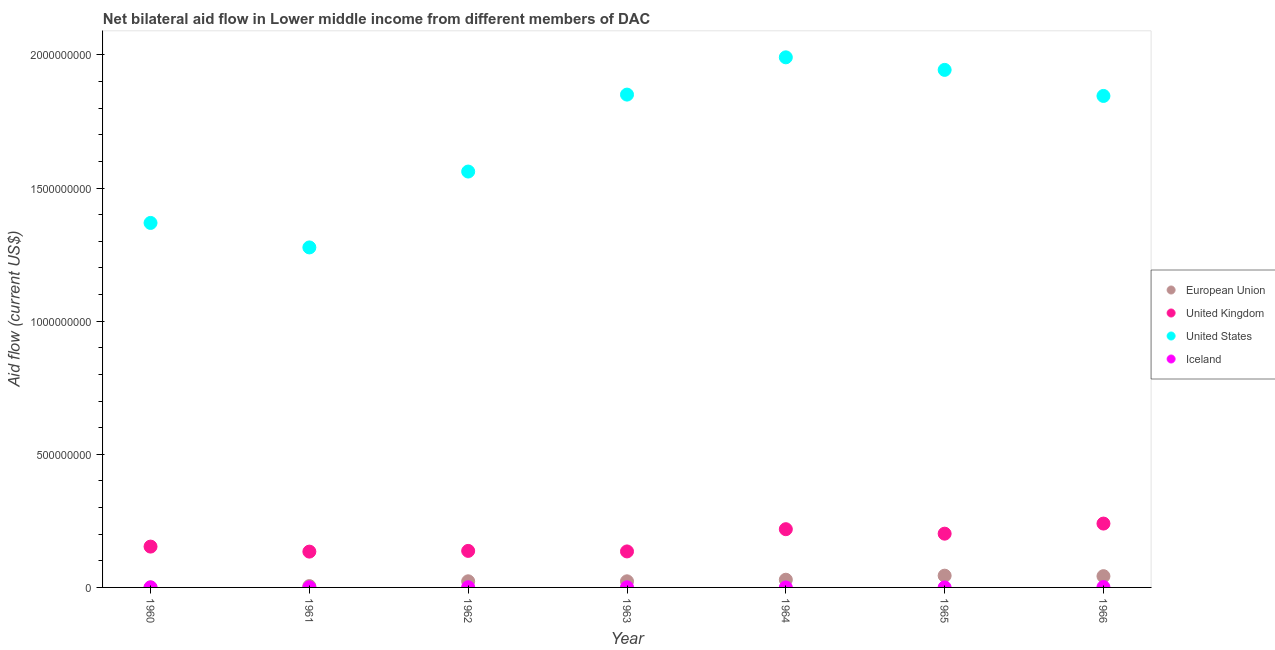What is the amount of aid given by uk in 1966?
Give a very brief answer. 2.40e+08. Across all years, what is the maximum amount of aid given by eu?
Give a very brief answer. 4.42e+07. Across all years, what is the minimum amount of aid given by uk?
Provide a succinct answer. 1.34e+08. In which year was the amount of aid given by uk maximum?
Make the answer very short. 1966. What is the total amount of aid given by iceland in the graph?
Provide a succinct answer. 3.41e+06. What is the difference between the amount of aid given by iceland in 1963 and that in 1964?
Provide a succinct answer. 4.20e+05. What is the difference between the amount of aid given by uk in 1966 and the amount of aid given by eu in 1963?
Ensure brevity in your answer.  2.17e+08. What is the average amount of aid given by us per year?
Make the answer very short. 1.69e+09. In the year 1961, what is the difference between the amount of aid given by iceland and amount of aid given by us?
Offer a very short reply. -1.28e+09. In how many years, is the amount of aid given by eu greater than 1000000000 US$?
Your answer should be compact. 0. What is the ratio of the amount of aid given by us in 1961 to that in 1966?
Make the answer very short. 0.69. Is the amount of aid given by iceland in 1963 less than that in 1965?
Offer a very short reply. No. What is the difference between the highest and the second highest amount of aid given by us?
Give a very brief answer. 4.71e+07. What is the difference between the highest and the lowest amount of aid given by iceland?
Offer a very short reply. 1.36e+06. Is it the case that in every year, the sum of the amount of aid given by eu and amount of aid given by uk is greater than the amount of aid given by us?
Make the answer very short. No. Is the amount of aid given by eu strictly greater than the amount of aid given by iceland over the years?
Ensure brevity in your answer.  Yes. Is the amount of aid given by us strictly less than the amount of aid given by iceland over the years?
Provide a succinct answer. No. How many dotlines are there?
Offer a very short reply. 4. What is the difference between two consecutive major ticks on the Y-axis?
Make the answer very short. 5.00e+08. Does the graph contain any zero values?
Offer a very short reply. No. Where does the legend appear in the graph?
Provide a short and direct response. Center right. How many legend labels are there?
Give a very brief answer. 4. What is the title of the graph?
Your answer should be compact. Net bilateral aid flow in Lower middle income from different members of DAC. What is the label or title of the X-axis?
Make the answer very short. Year. What is the label or title of the Y-axis?
Offer a terse response. Aid flow (current US$). What is the Aid flow (current US$) in United Kingdom in 1960?
Provide a succinct answer. 1.53e+08. What is the Aid flow (current US$) of United States in 1960?
Keep it short and to the point. 1.37e+09. What is the Aid flow (current US$) of Iceland in 1960?
Provide a succinct answer. 1.00e+05. What is the Aid flow (current US$) in European Union in 1961?
Keep it short and to the point. 5.04e+06. What is the Aid flow (current US$) of United Kingdom in 1961?
Provide a succinct answer. 1.34e+08. What is the Aid flow (current US$) of United States in 1961?
Make the answer very short. 1.28e+09. What is the Aid flow (current US$) of Iceland in 1961?
Your answer should be compact. 4.70e+05. What is the Aid flow (current US$) of European Union in 1962?
Make the answer very short. 2.30e+07. What is the Aid flow (current US$) of United Kingdom in 1962?
Give a very brief answer. 1.37e+08. What is the Aid flow (current US$) in United States in 1962?
Ensure brevity in your answer.  1.56e+09. What is the Aid flow (current US$) of Iceland in 1962?
Your response must be concise. 7.20e+05. What is the Aid flow (current US$) of European Union in 1963?
Your answer should be very brief. 2.30e+07. What is the Aid flow (current US$) in United Kingdom in 1963?
Your answer should be very brief. 1.35e+08. What is the Aid flow (current US$) of United States in 1963?
Keep it short and to the point. 1.85e+09. What is the Aid flow (current US$) in Iceland in 1963?
Provide a short and direct response. 5.30e+05. What is the Aid flow (current US$) of European Union in 1964?
Keep it short and to the point. 2.89e+07. What is the Aid flow (current US$) of United Kingdom in 1964?
Your response must be concise. 2.19e+08. What is the Aid flow (current US$) in United States in 1964?
Provide a succinct answer. 1.99e+09. What is the Aid flow (current US$) of Iceland in 1964?
Your answer should be compact. 1.10e+05. What is the Aid flow (current US$) of European Union in 1965?
Keep it short and to the point. 4.42e+07. What is the Aid flow (current US$) in United Kingdom in 1965?
Keep it short and to the point. 2.02e+08. What is the Aid flow (current US$) in United States in 1965?
Your answer should be compact. 1.94e+09. What is the Aid flow (current US$) in Iceland in 1965?
Make the answer very short. 6.00e+04. What is the Aid flow (current US$) in European Union in 1966?
Give a very brief answer. 4.23e+07. What is the Aid flow (current US$) in United Kingdom in 1966?
Your answer should be compact. 2.40e+08. What is the Aid flow (current US$) of United States in 1966?
Keep it short and to the point. 1.85e+09. What is the Aid flow (current US$) in Iceland in 1966?
Keep it short and to the point. 1.42e+06. Across all years, what is the maximum Aid flow (current US$) in European Union?
Your answer should be compact. 4.42e+07. Across all years, what is the maximum Aid flow (current US$) in United Kingdom?
Make the answer very short. 2.40e+08. Across all years, what is the maximum Aid flow (current US$) of United States?
Your answer should be very brief. 1.99e+09. Across all years, what is the maximum Aid flow (current US$) of Iceland?
Ensure brevity in your answer.  1.42e+06. Across all years, what is the minimum Aid flow (current US$) in United Kingdom?
Give a very brief answer. 1.34e+08. Across all years, what is the minimum Aid flow (current US$) in United States?
Offer a very short reply. 1.28e+09. What is the total Aid flow (current US$) in European Union in the graph?
Provide a succinct answer. 1.67e+08. What is the total Aid flow (current US$) of United Kingdom in the graph?
Offer a very short reply. 1.22e+09. What is the total Aid flow (current US$) in United States in the graph?
Provide a succinct answer. 1.18e+1. What is the total Aid flow (current US$) in Iceland in the graph?
Offer a very short reply. 3.41e+06. What is the difference between the Aid flow (current US$) in European Union in 1960 and that in 1961?
Offer a terse response. -4.82e+06. What is the difference between the Aid flow (current US$) of United Kingdom in 1960 and that in 1961?
Provide a succinct answer. 1.89e+07. What is the difference between the Aid flow (current US$) of United States in 1960 and that in 1961?
Offer a very short reply. 9.20e+07. What is the difference between the Aid flow (current US$) in Iceland in 1960 and that in 1961?
Give a very brief answer. -3.70e+05. What is the difference between the Aid flow (current US$) of European Union in 1960 and that in 1962?
Provide a succinct answer. -2.28e+07. What is the difference between the Aid flow (current US$) of United Kingdom in 1960 and that in 1962?
Your answer should be compact. 1.62e+07. What is the difference between the Aid flow (current US$) in United States in 1960 and that in 1962?
Ensure brevity in your answer.  -1.93e+08. What is the difference between the Aid flow (current US$) in Iceland in 1960 and that in 1962?
Your response must be concise. -6.20e+05. What is the difference between the Aid flow (current US$) in European Union in 1960 and that in 1963?
Your answer should be compact. -2.28e+07. What is the difference between the Aid flow (current US$) of United Kingdom in 1960 and that in 1963?
Ensure brevity in your answer.  1.82e+07. What is the difference between the Aid flow (current US$) of United States in 1960 and that in 1963?
Make the answer very short. -4.82e+08. What is the difference between the Aid flow (current US$) in Iceland in 1960 and that in 1963?
Your answer should be very brief. -4.30e+05. What is the difference between the Aid flow (current US$) of European Union in 1960 and that in 1964?
Offer a terse response. -2.87e+07. What is the difference between the Aid flow (current US$) of United Kingdom in 1960 and that in 1964?
Your answer should be compact. -6.54e+07. What is the difference between the Aid flow (current US$) of United States in 1960 and that in 1964?
Your answer should be compact. -6.22e+08. What is the difference between the Aid flow (current US$) in Iceland in 1960 and that in 1964?
Offer a very short reply. -10000. What is the difference between the Aid flow (current US$) in European Union in 1960 and that in 1965?
Provide a short and direct response. -4.39e+07. What is the difference between the Aid flow (current US$) of United Kingdom in 1960 and that in 1965?
Make the answer very short. -4.86e+07. What is the difference between the Aid flow (current US$) in United States in 1960 and that in 1965?
Offer a terse response. -5.75e+08. What is the difference between the Aid flow (current US$) in European Union in 1960 and that in 1966?
Your answer should be very brief. -4.20e+07. What is the difference between the Aid flow (current US$) in United Kingdom in 1960 and that in 1966?
Make the answer very short. -8.65e+07. What is the difference between the Aid flow (current US$) of United States in 1960 and that in 1966?
Ensure brevity in your answer.  -4.77e+08. What is the difference between the Aid flow (current US$) of Iceland in 1960 and that in 1966?
Provide a short and direct response. -1.32e+06. What is the difference between the Aid flow (current US$) in European Union in 1961 and that in 1962?
Ensure brevity in your answer.  -1.80e+07. What is the difference between the Aid flow (current US$) in United Kingdom in 1961 and that in 1962?
Ensure brevity in your answer.  -2.70e+06. What is the difference between the Aid flow (current US$) in United States in 1961 and that in 1962?
Your answer should be compact. -2.85e+08. What is the difference between the Aid flow (current US$) of European Union in 1961 and that in 1963?
Give a very brief answer. -1.79e+07. What is the difference between the Aid flow (current US$) in United Kingdom in 1961 and that in 1963?
Keep it short and to the point. -7.10e+05. What is the difference between the Aid flow (current US$) of United States in 1961 and that in 1963?
Your answer should be very brief. -5.74e+08. What is the difference between the Aid flow (current US$) in European Union in 1961 and that in 1964?
Offer a terse response. -2.39e+07. What is the difference between the Aid flow (current US$) of United Kingdom in 1961 and that in 1964?
Your response must be concise. -8.42e+07. What is the difference between the Aid flow (current US$) of United States in 1961 and that in 1964?
Offer a very short reply. -7.14e+08. What is the difference between the Aid flow (current US$) of Iceland in 1961 and that in 1964?
Your response must be concise. 3.60e+05. What is the difference between the Aid flow (current US$) of European Union in 1961 and that in 1965?
Your response must be concise. -3.91e+07. What is the difference between the Aid flow (current US$) in United Kingdom in 1961 and that in 1965?
Your answer should be compact. -6.74e+07. What is the difference between the Aid flow (current US$) of United States in 1961 and that in 1965?
Offer a terse response. -6.67e+08. What is the difference between the Aid flow (current US$) in Iceland in 1961 and that in 1965?
Keep it short and to the point. 4.10e+05. What is the difference between the Aid flow (current US$) of European Union in 1961 and that in 1966?
Your answer should be compact. -3.72e+07. What is the difference between the Aid flow (current US$) of United Kingdom in 1961 and that in 1966?
Give a very brief answer. -1.05e+08. What is the difference between the Aid flow (current US$) of United States in 1961 and that in 1966?
Ensure brevity in your answer.  -5.69e+08. What is the difference between the Aid flow (current US$) of Iceland in 1961 and that in 1966?
Make the answer very short. -9.50e+05. What is the difference between the Aid flow (current US$) of United Kingdom in 1962 and that in 1963?
Give a very brief answer. 1.99e+06. What is the difference between the Aid flow (current US$) of United States in 1962 and that in 1963?
Give a very brief answer. -2.89e+08. What is the difference between the Aid flow (current US$) of European Union in 1962 and that in 1964?
Provide a succinct answer. -5.88e+06. What is the difference between the Aid flow (current US$) of United Kingdom in 1962 and that in 1964?
Provide a succinct answer. -8.15e+07. What is the difference between the Aid flow (current US$) in United States in 1962 and that in 1964?
Your response must be concise. -4.29e+08. What is the difference between the Aid flow (current US$) in European Union in 1962 and that in 1965?
Offer a terse response. -2.11e+07. What is the difference between the Aid flow (current US$) in United Kingdom in 1962 and that in 1965?
Offer a terse response. -6.47e+07. What is the difference between the Aid flow (current US$) of United States in 1962 and that in 1965?
Keep it short and to the point. -3.82e+08. What is the difference between the Aid flow (current US$) of Iceland in 1962 and that in 1965?
Provide a succinct answer. 6.60e+05. What is the difference between the Aid flow (current US$) of European Union in 1962 and that in 1966?
Make the answer very short. -1.92e+07. What is the difference between the Aid flow (current US$) of United Kingdom in 1962 and that in 1966?
Offer a very short reply. -1.03e+08. What is the difference between the Aid flow (current US$) in United States in 1962 and that in 1966?
Offer a very short reply. -2.84e+08. What is the difference between the Aid flow (current US$) in Iceland in 1962 and that in 1966?
Offer a very short reply. -7.00e+05. What is the difference between the Aid flow (current US$) in European Union in 1963 and that in 1964?
Your answer should be compact. -5.95e+06. What is the difference between the Aid flow (current US$) of United Kingdom in 1963 and that in 1964?
Ensure brevity in your answer.  -8.35e+07. What is the difference between the Aid flow (current US$) of United States in 1963 and that in 1964?
Your response must be concise. -1.40e+08. What is the difference between the Aid flow (current US$) in European Union in 1963 and that in 1965?
Provide a succinct answer. -2.12e+07. What is the difference between the Aid flow (current US$) of United Kingdom in 1963 and that in 1965?
Offer a terse response. -6.67e+07. What is the difference between the Aid flow (current US$) of United States in 1963 and that in 1965?
Your response must be concise. -9.29e+07. What is the difference between the Aid flow (current US$) in Iceland in 1963 and that in 1965?
Your answer should be very brief. 4.70e+05. What is the difference between the Aid flow (current US$) in European Union in 1963 and that in 1966?
Ensure brevity in your answer.  -1.93e+07. What is the difference between the Aid flow (current US$) in United Kingdom in 1963 and that in 1966?
Offer a terse response. -1.05e+08. What is the difference between the Aid flow (current US$) of United States in 1963 and that in 1966?
Offer a very short reply. 5.02e+06. What is the difference between the Aid flow (current US$) of Iceland in 1963 and that in 1966?
Offer a terse response. -8.90e+05. What is the difference between the Aid flow (current US$) in European Union in 1964 and that in 1965?
Offer a very short reply. -1.52e+07. What is the difference between the Aid flow (current US$) in United Kingdom in 1964 and that in 1965?
Make the answer very short. 1.68e+07. What is the difference between the Aid flow (current US$) in United States in 1964 and that in 1965?
Your answer should be very brief. 4.71e+07. What is the difference between the Aid flow (current US$) in European Union in 1964 and that in 1966?
Your answer should be very brief. -1.34e+07. What is the difference between the Aid flow (current US$) in United Kingdom in 1964 and that in 1966?
Provide a short and direct response. -2.11e+07. What is the difference between the Aid flow (current US$) in United States in 1964 and that in 1966?
Give a very brief answer. 1.45e+08. What is the difference between the Aid flow (current US$) in Iceland in 1964 and that in 1966?
Provide a short and direct response. -1.31e+06. What is the difference between the Aid flow (current US$) in European Union in 1965 and that in 1966?
Ensure brevity in your answer.  1.88e+06. What is the difference between the Aid flow (current US$) in United Kingdom in 1965 and that in 1966?
Your answer should be very brief. -3.79e+07. What is the difference between the Aid flow (current US$) in United States in 1965 and that in 1966?
Provide a succinct answer. 9.79e+07. What is the difference between the Aid flow (current US$) in Iceland in 1965 and that in 1966?
Your answer should be compact. -1.36e+06. What is the difference between the Aid flow (current US$) in European Union in 1960 and the Aid flow (current US$) in United Kingdom in 1961?
Your answer should be compact. -1.34e+08. What is the difference between the Aid flow (current US$) of European Union in 1960 and the Aid flow (current US$) of United States in 1961?
Offer a very short reply. -1.28e+09. What is the difference between the Aid flow (current US$) in United Kingdom in 1960 and the Aid flow (current US$) in United States in 1961?
Provide a succinct answer. -1.12e+09. What is the difference between the Aid flow (current US$) of United Kingdom in 1960 and the Aid flow (current US$) of Iceland in 1961?
Provide a short and direct response. 1.53e+08. What is the difference between the Aid flow (current US$) in United States in 1960 and the Aid flow (current US$) in Iceland in 1961?
Give a very brief answer. 1.37e+09. What is the difference between the Aid flow (current US$) in European Union in 1960 and the Aid flow (current US$) in United Kingdom in 1962?
Your response must be concise. -1.37e+08. What is the difference between the Aid flow (current US$) in European Union in 1960 and the Aid flow (current US$) in United States in 1962?
Your answer should be very brief. -1.56e+09. What is the difference between the Aid flow (current US$) of European Union in 1960 and the Aid flow (current US$) of Iceland in 1962?
Your response must be concise. -5.00e+05. What is the difference between the Aid flow (current US$) of United Kingdom in 1960 and the Aid flow (current US$) of United States in 1962?
Your answer should be compact. -1.41e+09. What is the difference between the Aid flow (current US$) of United Kingdom in 1960 and the Aid flow (current US$) of Iceland in 1962?
Provide a succinct answer. 1.53e+08. What is the difference between the Aid flow (current US$) of United States in 1960 and the Aid flow (current US$) of Iceland in 1962?
Your answer should be compact. 1.37e+09. What is the difference between the Aid flow (current US$) of European Union in 1960 and the Aid flow (current US$) of United Kingdom in 1963?
Your answer should be compact. -1.35e+08. What is the difference between the Aid flow (current US$) of European Union in 1960 and the Aid flow (current US$) of United States in 1963?
Your answer should be very brief. -1.85e+09. What is the difference between the Aid flow (current US$) in European Union in 1960 and the Aid flow (current US$) in Iceland in 1963?
Keep it short and to the point. -3.10e+05. What is the difference between the Aid flow (current US$) in United Kingdom in 1960 and the Aid flow (current US$) in United States in 1963?
Provide a succinct answer. -1.70e+09. What is the difference between the Aid flow (current US$) in United Kingdom in 1960 and the Aid flow (current US$) in Iceland in 1963?
Keep it short and to the point. 1.53e+08. What is the difference between the Aid flow (current US$) of United States in 1960 and the Aid flow (current US$) of Iceland in 1963?
Keep it short and to the point. 1.37e+09. What is the difference between the Aid flow (current US$) in European Union in 1960 and the Aid flow (current US$) in United Kingdom in 1964?
Provide a succinct answer. -2.18e+08. What is the difference between the Aid flow (current US$) in European Union in 1960 and the Aid flow (current US$) in United States in 1964?
Your response must be concise. -1.99e+09. What is the difference between the Aid flow (current US$) in United Kingdom in 1960 and the Aid flow (current US$) in United States in 1964?
Offer a terse response. -1.84e+09. What is the difference between the Aid flow (current US$) in United Kingdom in 1960 and the Aid flow (current US$) in Iceland in 1964?
Offer a very short reply. 1.53e+08. What is the difference between the Aid flow (current US$) of United States in 1960 and the Aid flow (current US$) of Iceland in 1964?
Keep it short and to the point. 1.37e+09. What is the difference between the Aid flow (current US$) in European Union in 1960 and the Aid flow (current US$) in United Kingdom in 1965?
Make the answer very short. -2.02e+08. What is the difference between the Aid flow (current US$) of European Union in 1960 and the Aid flow (current US$) of United States in 1965?
Provide a succinct answer. -1.94e+09. What is the difference between the Aid flow (current US$) in United Kingdom in 1960 and the Aid flow (current US$) in United States in 1965?
Your answer should be very brief. -1.79e+09. What is the difference between the Aid flow (current US$) of United Kingdom in 1960 and the Aid flow (current US$) of Iceland in 1965?
Offer a very short reply. 1.53e+08. What is the difference between the Aid flow (current US$) of United States in 1960 and the Aid flow (current US$) of Iceland in 1965?
Make the answer very short. 1.37e+09. What is the difference between the Aid flow (current US$) in European Union in 1960 and the Aid flow (current US$) in United Kingdom in 1966?
Offer a very short reply. -2.40e+08. What is the difference between the Aid flow (current US$) of European Union in 1960 and the Aid flow (current US$) of United States in 1966?
Your answer should be very brief. -1.85e+09. What is the difference between the Aid flow (current US$) in European Union in 1960 and the Aid flow (current US$) in Iceland in 1966?
Your answer should be compact. -1.20e+06. What is the difference between the Aid flow (current US$) of United Kingdom in 1960 and the Aid flow (current US$) of United States in 1966?
Keep it short and to the point. -1.69e+09. What is the difference between the Aid flow (current US$) of United Kingdom in 1960 and the Aid flow (current US$) of Iceland in 1966?
Provide a short and direct response. 1.52e+08. What is the difference between the Aid flow (current US$) in United States in 1960 and the Aid flow (current US$) in Iceland in 1966?
Provide a succinct answer. 1.37e+09. What is the difference between the Aid flow (current US$) in European Union in 1961 and the Aid flow (current US$) in United Kingdom in 1962?
Offer a terse response. -1.32e+08. What is the difference between the Aid flow (current US$) in European Union in 1961 and the Aid flow (current US$) in United States in 1962?
Give a very brief answer. -1.56e+09. What is the difference between the Aid flow (current US$) in European Union in 1961 and the Aid flow (current US$) in Iceland in 1962?
Provide a short and direct response. 4.32e+06. What is the difference between the Aid flow (current US$) of United Kingdom in 1961 and the Aid flow (current US$) of United States in 1962?
Offer a terse response. -1.43e+09. What is the difference between the Aid flow (current US$) of United Kingdom in 1961 and the Aid flow (current US$) of Iceland in 1962?
Keep it short and to the point. 1.34e+08. What is the difference between the Aid flow (current US$) of United States in 1961 and the Aid flow (current US$) of Iceland in 1962?
Provide a succinct answer. 1.28e+09. What is the difference between the Aid flow (current US$) of European Union in 1961 and the Aid flow (current US$) of United Kingdom in 1963?
Make the answer very short. -1.30e+08. What is the difference between the Aid flow (current US$) of European Union in 1961 and the Aid flow (current US$) of United States in 1963?
Provide a short and direct response. -1.85e+09. What is the difference between the Aid flow (current US$) of European Union in 1961 and the Aid flow (current US$) of Iceland in 1963?
Make the answer very short. 4.51e+06. What is the difference between the Aid flow (current US$) in United Kingdom in 1961 and the Aid flow (current US$) in United States in 1963?
Ensure brevity in your answer.  -1.72e+09. What is the difference between the Aid flow (current US$) in United Kingdom in 1961 and the Aid flow (current US$) in Iceland in 1963?
Your answer should be very brief. 1.34e+08. What is the difference between the Aid flow (current US$) of United States in 1961 and the Aid flow (current US$) of Iceland in 1963?
Make the answer very short. 1.28e+09. What is the difference between the Aid flow (current US$) in European Union in 1961 and the Aid flow (current US$) in United Kingdom in 1964?
Give a very brief answer. -2.14e+08. What is the difference between the Aid flow (current US$) in European Union in 1961 and the Aid flow (current US$) in United States in 1964?
Provide a short and direct response. -1.99e+09. What is the difference between the Aid flow (current US$) of European Union in 1961 and the Aid flow (current US$) of Iceland in 1964?
Offer a terse response. 4.93e+06. What is the difference between the Aid flow (current US$) of United Kingdom in 1961 and the Aid flow (current US$) of United States in 1964?
Offer a terse response. -1.86e+09. What is the difference between the Aid flow (current US$) in United Kingdom in 1961 and the Aid flow (current US$) in Iceland in 1964?
Your answer should be compact. 1.34e+08. What is the difference between the Aid flow (current US$) of United States in 1961 and the Aid flow (current US$) of Iceland in 1964?
Offer a very short reply. 1.28e+09. What is the difference between the Aid flow (current US$) in European Union in 1961 and the Aid flow (current US$) in United Kingdom in 1965?
Ensure brevity in your answer.  -1.97e+08. What is the difference between the Aid flow (current US$) of European Union in 1961 and the Aid flow (current US$) of United States in 1965?
Offer a very short reply. -1.94e+09. What is the difference between the Aid flow (current US$) in European Union in 1961 and the Aid flow (current US$) in Iceland in 1965?
Your answer should be very brief. 4.98e+06. What is the difference between the Aid flow (current US$) in United Kingdom in 1961 and the Aid flow (current US$) in United States in 1965?
Your answer should be compact. -1.81e+09. What is the difference between the Aid flow (current US$) in United Kingdom in 1961 and the Aid flow (current US$) in Iceland in 1965?
Give a very brief answer. 1.34e+08. What is the difference between the Aid flow (current US$) in United States in 1961 and the Aid flow (current US$) in Iceland in 1965?
Give a very brief answer. 1.28e+09. What is the difference between the Aid flow (current US$) of European Union in 1961 and the Aid flow (current US$) of United Kingdom in 1966?
Offer a very short reply. -2.35e+08. What is the difference between the Aid flow (current US$) in European Union in 1961 and the Aid flow (current US$) in United States in 1966?
Provide a short and direct response. -1.84e+09. What is the difference between the Aid flow (current US$) in European Union in 1961 and the Aid flow (current US$) in Iceland in 1966?
Ensure brevity in your answer.  3.62e+06. What is the difference between the Aid flow (current US$) of United Kingdom in 1961 and the Aid flow (current US$) of United States in 1966?
Ensure brevity in your answer.  -1.71e+09. What is the difference between the Aid flow (current US$) in United Kingdom in 1961 and the Aid flow (current US$) in Iceland in 1966?
Offer a very short reply. 1.33e+08. What is the difference between the Aid flow (current US$) of United States in 1961 and the Aid flow (current US$) of Iceland in 1966?
Provide a short and direct response. 1.28e+09. What is the difference between the Aid flow (current US$) of European Union in 1962 and the Aid flow (current US$) of United Kingdom in 1963?
Give a very brief answer. -1.12e+08. What is the difference between the Aid flow (current US$) in European Union in 1962 and the Aid flow (current US$) in United States in 1963?
Give a very brief answer. -1.83e+09. What is the difference between the Aid flow (current US$) of European Union in 1962 and the Aid flow (current US$) of Iceland in 1963?
Make the answer very short. 2.25e+07. What is the difference between the Aid flow (current US$) of United Kingdom in 1962 and the Aid flow (current US$) of United States in 1963?
Provide a succinct answer. -1.71e+09. What is the difference between the Aid flow (current US$) in United Kingdom in 1962 and the Aid flow (current US$) in Iceland in 1963?
Offer a very short reply. 1.37e+08. What is the difference between the Aid flow (current US$) in United States in 1962 and the Aid flow (current US$) in Iceland in 1963?
Give a very brief answer. 1.56e+09. What is the difference between the Aid flow (current US$) of European Union in 1962 and the Aid flow (current US$) of United Kingdom in 1964?
Provide a succinct answer. -1.96e+08. What is the difference between the Aid flow (current US$) in European Union in 1962 and the Aid flow (current US$) in United States in 1964?
Offer a very short reply. -1.97e+09. What is the difference between the Aid flow (current US$) in European Union in 1962 and the Aid flow (current US$) in Iceland in 1964?
Offer a terse response. 2.29e+07. What is the difference between the Aid flow (current US$) of United Kingdom in 1962 and the Aid flow (current US$) of United States in 1964?
Give a very brief answer. -1.85e+09. What is the difference between the Aid flow (current US$) of United Kingdom in 1962 and the Aid flow (current US$) of Iceland in 1964?
Your answer should be compact. 1.37e+08. What is the difference between the Aid flow (current US$) of United States in 1962 and the Aid flow (current US$) of Iceland in 1964?
Give a very brief answer. 1.56e+09. What is the difference between the Aid flow (current US$) in European Union in 1962 and the Aid flow (current US$) in United Kingdom in 1965?
Your answer should be very brief. -1.79e+08. What is the difference between the Aid flow (current US$) of European Union in 1962 and the Aid flow (current US$) of United States in 1965?
Provide a succinct answer. -1.92e+09. What is the difference between the Aid flow (current US$) of European Union in 1962 and the Aid flow (current US$) of Iceland in 1965?
Give a very brief answer. 2.30e+07. What is the difference between the Aid flow (current US$) of United Kingdom in 1962 and the Aid flow (current US$) of United States in 1965?
Make the answer very short. -1.81e+09. What is the difference between the Aid flow (current US$) in United Kingdom in 1962 and the Aid flow (current US$) in Iceland in 1965?
Your answer should be compact. 1.37e+08. What is the difference between the Aid flow (current US$) of United States in 1962 and the Aid flow (current US$) of Iceland in 1965?
Your answer should be very brief. 1.56e+09. What is the difference between the Aid flow (current US$) of European Union in 1962 and the Aid flow (current US$) of United Kingdom in 1966?
Give a very brief answer. -2.17e+08. What is the difference between the Aid flow (current US$) of European Union in 1962 and the Aid flow (current US$) of United States in 1966?
Your answer should be very brief. -1.82e+09. What is the difference between the Aid flow (current US$) of European Union in 1962 and the Aid flow (current US$) of Iceland in 1966?
Make the answer very short. 2.16e+07. What is the difference between the Aid flow (current US$) of United Kingdom in 1962 and the Aid flow (current US$) of United States in 1966?
Provide a short and direct response. -1.71e+09. What is the difference between the Aid flow (current US$) of United Kingdom in 1962 and the Aid flow (current US$) of Iceland in 1966?
Your answer should be compact. 1.36e+08. What is the difference between the Aid flow (current US$) in United States in 1962 and the Aid flow (current US$) in Iceland in 1966?
Your answer should be very brief. 1.56e+09. What is the difference between the Aid flow (current US$) in European Union in 1963 and the Aid flow (current US$) in United Kingdom in 1964?
Make the answer very short. -1.96e+08. What is the difference between the Aid flow (current US$) of European Union in 1963 and the Aid flow (current US$) of United States in 1964?
Make the answer very short. -1.97e+09. What is the difference between the Aid flow (current US$) in European Union in 1963 and the Aid flow (current US$) in Iceland in 1964?
Your answer should be very brief. 2.29e+07. What is the difference between the Aid flow (current US$) of United Kingdom in 1963 and the Aid flow (current US$) of United States in 1964?
Offer a terse response. -1.86e+09. What is the difference between the Aid flow (current US$) in United Kingdom in 1963 and the Aid flow (current US$) in Iceland in 1964?
Keep it short and to the point. 1.35e+08. What is the difference between the Aid flow (current US$) in United States in 1963 and the Aid flow (current US$) in Iceland in 1964?
Provide a short and direct response. 1.85e+09. What is the difference between the Aid flow (current US$) of European Union in 1963 and the Aid flow (current US$) of United Kingdom in 1965?
Offer a very short reply. -1.79e+08. What is the difference between the Aid flow (current US$) of European Union in 1963 and the Aid flow (current US$) of United States in 1965?
Give a very brief answer. -1.92e+09. What is the difference between the Aid flow (current US$) in European Union in 1963 and the Aid flow (current US$) in Iceland in 1965?
Provide a succinct answer. 2.29e+07. What is the difference between the Aid flow (current US$) of United Kingdom in 1963 and the Aid flow (current US$) of United States in 1965?
Offer a very short reply. -1.81e+09. What is the difference between the Aid flow (current US$) in United Kingdom in 1963 and the Aid flow (current US$) in Iceland in 1965?
Offer a terse response. 1.35e+08. What is the difference between the Aid flow (current US$) in United States in 1963 and the Aid flow (current US$) in Iceland in 1965?
Ensure brevity in your answer.  1.85e+09. What is the difference between the Aid flow (current US$) in European Union in 1963 and the Aid flow (current US$) in United Kingdom in 1966?
Your response must be concise. -2.17e+08. What is the difference between the Aid flow (current US$) of European Union in 1963 and the Aid flow (current US$) of United States in 1966?
Your answer should be compact. -1.82e+09. What is the difference between the Aid flow (current US$) of European Union in 1963 and the Aid flow (current US$) of Iceland in 1966?
Make the answer very short. 2.16e+07. What is the difference between the Aid flow (current US$) in United Kingdom in 1963 and the Aid flow (current US$) in United States in 1966?
Offer a terse response. -1.71e+09. What is the difference between the Aid flow (current US$) in United Kingdom in 1963 and the Aid flow (current US$) in Iceland in 1966?
Offer a terse response. 1.34e+08. What is the difference between the Aid flow (current US$) of United States in 1963 and the Aid flow (current US$) of Iceland in 1966?
Your response must be concise. 1.85e+09. What is the difference between the Aid flow (current US$) in European Union in 1964 and the Aid flow (current US$) in United Kingdom in 1965?
Keep it short and to the point. -1.73e+08. What is the difference between the Aid flow (current US$) of European Union in 1964 and the Aid flow (current US$) of United States in 1965?
Ensure brevity in your answer.  -1.91e+09. What is the difference between the Aid flow (current US$) in European Union in 1964 and the Aid flow (current US$) in Iceland in 1965?
Your response must be concise. 2.89e+07. What is the difference between the Aid flow (current US$) of United Kingdom in 1964 and the Aid flow (current US$) of United States in 1965?
Ensure brevity in your answer.  -1.73e+09. What is the difference between the Aid flow (current US$) in United Kingdom in 1964 and the Aid flow (current US$) in Iceland in 1965?
Offer a terse response. 2.19e+08. What is the difference between the Aid flow (current US$) in United States in 1964 and the Aid flow (current US$) in Iceland in 1965?
Keep it short and to the point. 1.99e+09. What is the difference between the Aid flow (current US$) of European Union in 1964 and the Aid flow (current US$) of United Kingdom in 1966?
Provide a succinct answer. -2.11e+08. What is the difference between the Aid flow (current US$) in European Union in 1964 and the Aid flow (current US$) in United States in 1966?
Make the answer very short. -1.82e+09. What is the difference between the Aid flow (current US$) in European Union in 1964 and the Aid flow (current US$) in Iceland in 1966?
Provide a short and direct response. 2.75e+07. What is the difference between the Aid flow (current US$) in United Kingdom in 1964 and the Aid flow (current US$) in United States in 1966?
Make the answer very short. -1.63e+09. What is the difference between the Aid flow (current US$) of United Kingdom in 1964 and the Aid flow (current US$) of Iceland in 1966?
Offer a very short reply. 2.17e+08. What is the difference between the Aid flow (current US$) in United States in 1964 and the Aid flow (current US$) in Iceland in 1966?
Give a very brief answer. 1.99e+09. What is the difference between the Aid flow (current US$) in European Union in 1965 and the Aid flow (current US$) in United Kingdom in 1966?
Keep it short and to the point. -1.96e+08. What is the difference between the Aid flow (current US$) of European Union in 1965 and the Aid flow (current US$) of United States in 1966?
Ensure brevity in your answer.  -1.80e+09. What is the difference between the Aid flow (current US$) of European Union in 1965 and the Aid flow (current US$) of Iceland in 1966?
Your answer should be compact. 4.27e+07. What is the difference between the Aid flow (current US$) in United Kingdom in 1965 and the Aid flow (current US$) in United States in 1966?
Provide a short and direct response. -1.64e+09. What is the difference between the Aid flow (current US$) in United Kingdom in 1965 and the Aid flow (current US$) in Iceland in 1966?
Your answer should be compact. 2.00e+08. What is the difference between the Aid flow (current US$) in United States in 1965 and the Aid flow (current US$) in Iceland in 1966?
Offer a very short reply. 1.94e+09. What is the average Aid flow (current US$) in European Union per year?
Ensure brevity in your answer.  2.38e+07. What is the average Aid flow (current US$) in United Kingdom per year?
Offer a terse response. 1.74e+08. What is the average Aid flow (current US$) of United States per year?
Provide a succinct answer. 1.69e+09. What is the average Aid flow (current US$) of Iceland per year?
Offer a very short reply. 4.87e+05. In the year 1960, what is the difference between the Aid flow (current US$) of European Union and Aid flow (current US$) of United Kingdom?
Keep it short and to the point. -1.53e+08. In the year 1960, what is the difference between the Aid flow (current US$) in European Union and Aid flow (current US$) in United States?
Make the answer very short. -1.37e+09. In the year 1960, what is the difference between the Aid flow (current US$) of United Kingdom and Aid flow (current US$) of United States?
Offer a very short reply. -1.22e+09. In the year 1960, what is the difference between the Aid flow (current US$) of United Kingdom and Aid flow (current US$) of Iceland?
Offer a terse response. 1.53e+08. In the year 1960, what is the difference between the Aid flow (current US$) of United States and Aid flow (current US$) of Iceland?
Give a very brief answer. 1.37e+09. In the year 1961, what is the difference between the Aid flow (current US$) of European Union and Aid flow (current US$) of United Kingdom?
Provide a short and direct response. -1.29e+08. In the year 1961, what is the difference between the Aid flow (current US$) in European Union and Aid flow (current US$) in United States?
Keep it short and to the point. -1.27e+09. In the year 1961, what is the difference between the Aid flow (current US$) of European Union and Aid flow (current US$) of Iceland?
Provide a succinct answer. 4.57e+06. In the year 1961, what is the difference between the Aid flow (current US$) of United Kingdom and Aid flow (current US$) of United States?
Give a very brief answer. -1.14e+09. In the year 1961, what is the difference between the Aid flow (current US$) in United Kingdom and Aid flow (current US$) in Iceland?
Your answer should be very brief. 1.34e+08. In the year 1961, what is the difference between the Aid flow (current US$) in United States and Aid flow (current US$) in Iceland?
Give a very brief answer. 1.28e+09. In the year 1962, what is the difference between the Aid flow (current US$) in European Union and Aid flow (current US$) in United Kingdom?
Offer a very short reply. -1.14e+08. In the year 1962, what is the difference between the Aid flow (current US$) in European Union and Aid flow (current US$) in United States?
Provide a short and direct response. -1.54e+09. In the year 1962, what is the difference between the Aid flow (current US$) in European Union and Aid flow (current US$) in Iceland?
Offer a terse response. 2.23e+07. In the year 1962, what is the difference between the Aid flow (current US$) in United Kingdom and Aid flow (current US$) in United States?
Your response must be concise. -1.42e+09. In the year 1962, what is the difference between the Aid flow (current US$) of United Kingdom and Aid flow (current US$) of Iceland?
Provide a succinct answer. 1.36e+08. In the year 1962, what is the difference between the Aid flow (current US$) of United States and Aid flow (current US$) of Iceland?
Provide a succinct answer. 1.56e+09. In the year 1963, what is the difference between the Aid flow (current US$) of European Union and Aid flow (current US$) of United Kingdom?
Offer a very short reply. -1.12e+08. In the year 1963, what is the difference between the Aid flow (current US$) of European Union and Aid flow (current US$) of United States?
Provide a short and direct response. -1.83e+09. In the year 1963, what is the difference between the Aid flow (current US$) of European Union and Aid flow (current US$) of Iceland?
Provide a short and direct response. 2.24e+07. In the year 1963, what is the difference between the Aid flow (current US$) of United Kingdom and Aid flow (current US$) of United States?
Make the answer very short. -1.72e+09. In the year 1963, what is the difference between the Aid flow (current US$) of United Kingdom and Aid flow (current US$) of Iceland?
Provide a short and direct response. 1.35e+08. In the year 1963, what is the difference between the Aid flow (current US$) of United States and Aid flow (current US$) of Iceland?
Make the answer very short. 1.85e+09. In the year 1964, what is the difference between the Aid flow (current US$) of European Union and Aid flow (current US$) of United Kingdom?
Offer a terse response. -1.90e+08. In the year 1964, what is the difference between the Aid flow (current US$) of European Union and Aid flow (current US$) of United States?
Offer a terse response. -1.96e+09. In the year 1964, what is the difference between the Aid flow (current US$) in European Union and Aid flow (current US$) in Iceland?
Give a very brief answer. 2.88e+07. In the year 1964, what is the difference between the Aid flow (current US$) of United Kingdom and Aid flow (current US$) of United States?
Your response must be concise. -1.77e+09. In the year 1964, what is the difference between the Aid flow (current US$) in United Kingdom and Aid flow (current US$) in Iceland?
Offer a terse response. 2.19e+08. In the year 1964, what is the difference between the Aid flow (current US$) in United States and Aid flow (current US$) in Iceland?
Keep it short and to the point. 1.99e+09. In the year 1965, what is the difference between the Aid flow (current US$) of European Union and Aid flow (current US$) of United Kingdom?
Your answer should be compact. -1.58e+08. In the year 1965, what is the difference between the Aid flow (current US$) of European Union and Aid flow (current US$) of United States?
Provide a succinct answer. -1.90e+09. In the year 1965, what is the difference between the Aid flow (current US$) in European Union and Aid flow (current US$) in Iceland?
Make the answer very short. 4.41e+07. In the year 1965, what is the difference between the Aid flow (current US$) of United Kingdom and Aid flow (current US$) of United States?
Ensure brevity in your answer.  -1.74e+09. In the year 1965, what is the difference between the Aid flow (current US$) of United Kingdom and Aid flow (current US$) of Iceland?
Offer a terse response. 2.02e+08. In the year 1965, what is the difference between the Aid flow (current US$) of United States and Aid flow (current US$) of Iceland?
Your answer should be compact. 1.94e+09. In the year 1966, what is the difference between the Aid flow (current US$) of European Union and Aid flow (current US$) of United Kingdom?
Your answer should be very brief. -1.98e+08. In the year 1966, what is the difference between the Aid flow (current US$) in European Union and Aid flow (current US$) in United States?
Your answer should be compact. -1.80e+09. In the year 1966, what is the difference between the Aid flow (current US$) in European Union and Aid flow (current US$) in Iceland?
Ensure brevity in your answer.  4.08e+07. In the year 1966, what is the difference between the Aid flow (current US$) in United Kingdom and Aid flow (current US$) in United States?
Offer a terse response. -1.61e+09. In the year 1966, what is the difference between the Aid flow (current US$) in United Kingdom and Aid flow (current US$) in Iceland?
Offer a terse response. 2.38e+08. In the year 1966, what is the difference between the Aid flow (current US$) in United States and Aid flow (current US$) in Iceland?
Make the answer very short. 1.84e+09. What is the ratio of the Aid flow (current US$) in European Union in 1960 to that in 1961?
Your answer should be very brief. 0.04. What is the ratio of the Aid flow (current US$) of United Kingdom in 1960 to that in 1961?
Ensure brevity in your answer.  1.14. What is the ratio of the Aid flow (current US$) of United States in 1960 to that in 1961?
Your response must be concise. 1.07. What is the ratio of the Aid flow (current US$) of Iceland in 1960 to that in 1961?
Your answer should be very brief. 0.21. What is the ratio of the Aid flow (current US$) of European Union in 1960 to that in 1962?
Make the answer very short. 0.01. What is the ratio of the Aid flow (current US$) of United Kingdom in 1960 to that in 1962?
Provide a short and direct response. 1.12. What is the ratio of the Aid flow (current US$) of United States in 1960 to that in 1962?
Give a very brief answer. 0.88. What is the ratio of the Aid flow (current US$) of Iceland in 1960 to that in 1962?
Your answer should be very brief. 0.14. What is the ratio of the Aid flow (current US$) in European Union in 1960 to that in 1963?
Offer a terse response. 0.01. What is the ratio of the Aid flow (current US$) in United Kingdom in 1960 to that in 1963?
Offer a terse response. 1.13. What is the ratio of the Aid flow (current US$) of United States in 1960 to that in 1963?
Ensure brevity in your answer.  0.74. What is the ratio of the Aid flow (current US$) in Iceland in 1960 to that in 1963?
Give a very brief answer. 0.19. What is the ratio of the Aid flow (current US$) of European Union in 1960 to that in 1964?
Offer a very short reply. 0.01. What is the ratio of the Aid flow (current US$) in United Kingdom in 1960 to that in 1964?
Ensure brevity in your answer.  0.7. What is the ratio of the Aid flow (current US$) of United States in 1960 to that in 1964?
Your answer should be very brief. 0.69. What is the ratio of the Aid flow (current US$) of Iceland in 1960 to that in 1964?
Give a very brief answer. 0.91. What is the ratio of the Aid flow (current US$) of European Union in 1960 to that in 1965?
Your answer should be very brief. 0.01. What is the ratio of the Aid flow (current US$) of United Kingdom in 1960 to that in 1965?
Your response must be concise. 0.76. What is the ratio of the Aid flow (current US$) of United States in 1960 to that in 1965?
Your answer should be compact. 0.7. What is the ratio of the Aid flow (current US$) of Iceland in 1960 to that in 1965?
Make the answer very short. 1.67. What is the ratio of the Aid flow (current US$) of European Union in 1960 to that in 1966?
Your answer should be compact. 0.01. What is the ratio of the Aid flow (current US$) of United Kingdom in 1960 to that in 1966?
Ensure brevity in your answer.  0.64. What is the ratio of the Aid flow (current US$) of United States in 1960 to that in 1966?
Make the answer very short. 0.74. What is the ratio of the Aid flow (current US$) in Iceland in 1960 to that in 1966?
Provide a succinct answer. 0.07. What is the ratio of the Aid flow (current US$) in European Union in 1961 to that in 1962?
Your response must be concise. 0.22. What is the ratio of the Aid flow (current US$) of United Kingdom in 1961 to that in 1962?
Your response must be concise. 0.98. What is the ratio of the Aid flow (current US$) in United States in 1961 to that in 1962?
Your response must be concise. 0.82. What is the ratio of the Aid flow (current US$) of Iceland in 1961 to that in 1962?
Provide a succinct answer. 0.65. What is the ratio of the Aid flow (current US$) in European Union in 1961 to that in 1963?
Keep it short and to the point. 0.22. What is the ratio of the Aid flow (current US$) of United States in 1961 to that in 1963?
Your answer should be compact. 0.69. What is the ratio of the Aid flow (current US$) in Iceland in 1961 to that in 1963?
Your answer should be compact. 0.89. What is the ratio of the Aid flow (current US$) in European Union in 1961 to that in 1964?
Provide a succinct answer. 0.17. What is the ratio of the Aid flow (current US$) of United Kingdom in 1961 to that in 1964?
Provide a short and direct response. 0.61. What is the ratio of the Aid flow (current US$) of United States in 1961 to that in 1964?
Provide a short and direct response. 0.64. What is the ratio of the Aid flow (current US$) in Iceland in 1961 to that in 1964?
Your answer should be compact. 4.27. What is the ratio of the Aid flow (current US$) in European Union in 1961 to that in 1965?
Offer a very short reply. 0.11. What is the ratio of the Aid flow (current US$) of United Kingdom in 1961 to that in 1965?
Your answer should be compact. 0.67. What is the ratio of the Aid flow (current US$) of United States in 1961 to that in 1965?
Your answer should be very brief. 0.66. What is the ratio of the Aid flow (current US$) of Iceland in 1961 to that in 1965?
Provide a succinct answer. 7.83. What is the ratio of the Aid flow (current US$) of European Union in 1961 to that in 1966?
Your answer should be very brief. 0.12. What is the ratio of the Aid flow (current US$) of United Kingdom in 1961 to that in 1966?
Give a very brief answer. 0.56. What is the ratio of the Aid flow (current US$) of United States in 1961 to that in 1966?
Provide a succinct answer. 0.69. What is the ratio of the Aid flow (current US$) of Iceland in 1961 to that in 1966?
Offer a terse response. 0.33. What is the ratio of the Aid flow (current US$) in European Union in 1962 to that in 1963?
Your answer should be very brief. 1. What is the ratio of the Aid flow (current US$) in United Kingdom in 1962 to that in 1963?
Provide a succinct answer. 1.01. What is the ratio of the Aid flow (current US$) of United States in 1962 to that in 1963?
Make the answer very short. 0.84. What is the ratio of the Aid flow (current US$) of Iceland in 1962 to that in 1963?
Your answer should be compact. 1.36. What is the ratio of the Aid flow (current US$) in European Union in 1962 to that in 1964?
Provide a short and direct response. 0.8. What is the ratio of the Aid flow (current US$) of United Kingdom in 1962 to that in 1964?
Give a very brief answer. 0.63. What is the ratio of the Aid flow (current US$) in United States in 1962 to that in 1964?
Make the answer very short. 0.78. What is the ratio of the Aid flow (current US$) in Iceland in 1962 to that in 1964?
Your response must be concise. 6.55. What is the ratio of the Aid flow (current US$) of European Union in 1962 to that in 1965?
Make the answer very short. 0.52. What is the ratio of the Aid flow (current US$) of United Kingdom in 1962 to that in 1965?
Keep it short and to the point. 0.68. What is the ratio of the Aid flow (current US$) in United States in 1962 to that in 1965?
Ensure brevity in your answer.  0.8. What is the ratio of the Aid flow (current US$) in European Union in 1962 to that in 1966?
Keep it short and to the point. 0.55. What is the ratio of the Aid flow (current US$) of United Kingdom in 1962 to that in 1966?
Offer a terse response. 0.57. What is the ratio of the Aid flow (current US$) in United States in 1962 to that in 1966?
Offer a very short reply. 0.85. What is the ratio of the Aid flow (current US$) of Iceland in 1962 to that in 1966?
Make the answer very short. 0.51. What is the ratio of the Aid flow (current US$) in European Union in 1963 to that in 1964?
Ensure brevity in your answer.  0.79. What is the ratio of the Aid flow (current US$) of United Kingdom in 1963 to that in 1964?
Offer a terse response. 0.62. What is the ratio of the Aid flow (current US$) of United States in 1963 to that in 1964?
Your answer should be very brief. 0.93. What is the ratio of the Aid flow (current US$) of Iceland in 1963 to that in 1964?
Your answer should be compact. 4.82. What is the ratio of the Aid flow (current US$) in European Union in 1963 to that in 1965?
Your answer should be compact. 0.52. What is the ratio of the Aid flow (current US$) of United Kingdom in 1963 to that in 1965?
Provide a succinct answer. 0.67. What is the ratio of the Aid flow (current US$) in United States in 1963 to that in 1965?
Offer a terse response. 0.95. What is the ratio of the Aid flow (current US$) of Iceland in 1963 to that in 1965?
Offer a terse response. 8.83. What is the ratio of the Aid flow (current US$) of European Union in 1963 to that in 1966?
Ensure brevity in your answer.  0.54. What is the ratio of the Aid flow (current US$) of United Kingdom in 1963 to that in 1966?
Provide a succinct answer. 0.56. What is the ratio of the Aid flow (current US$) of United States in 1963 to that in 1966?
Provide a succinct answer. 1. What is the ratio of the Aid flow (current US$) in Iceland in 1963 to that in 1966?
Offer a terse response. 0.37. What is the ratio of the Aid flow (current US$) in European Union in 1964 to that in 1965?
Your answer should be compact. 0.66. What is the ratio of the Aid flow (current US$) of United States in 1964 to that in 1965?
Keep it short and to the point. 1.02. What is the ratio of the Aid flow (current US$) in Iceland in 1964 to that in 1965?
Provide a short and direct response. 1.83. What is the ratio of the Aid flow (current US$) in European Union in 1964 to that in 1966?
Offer a terse response. 0.68. What is the ratio of the Aid flow (current US$) in United Kingdom in 1964 to that in 1966?
Ensure brevity in your answer.  0.91. What is the ratio of the Aid flow (current US$) in United States in 1964 to that in 1966?
Your answer should be compact. 1.08. What is the ratio of the Aid flow (current US$) in Iceland in 1964 to that in 1966?
Ensure brevity in your answer.  0.08. What is the ratio of the Aid flow (current US$) in European Union in 1965 to that in 1966?
Your response must be concise. 1.04. What is the ratio of the Aid flow (current US$) of United Kingdom in 1965 to that in 1966?
Keep it short and to the point. 0.84. What is the ratio of the Aid flow (current US$) of United States in 1965 to that in 1966?
Provide a short and direct response. 1.05. What is the ratio of the Aid flow (current US$) in Iceland in 1965 to that in 1966?
Your answer should be compact. 0.04. What is the difference between the highest and the second highest Aid flow (current US$) in European Union?
Provide a succinct answer. 1.88e+06. What is the difference between the highest and the second highest Aid flow (current US$) of United Kingdom?
Keep it short and to the point. 2.11e+07. What is the difference between the highest and the second highest Aid flow (current US$) in United States?
Make the answer very short. 4.71e+07. What is the difference between the highest and the lowest Aid flow (current US$) in European Union?
Your answer should be very brief. 4.39e+07. What is the difference between the highest and the lowest Aid flow (current US$) of United Kingdom?
Your response must be concise. 1.05e+08. What is the difference between the highest and the lowest Aid flow (current US$) of United States?
Provide a succinct answer. 7.14e+08. What is the difference between the highest and the lowest Aid flow (current US$) of Iceland?
Your answer should be compact. 1.36e+06. 